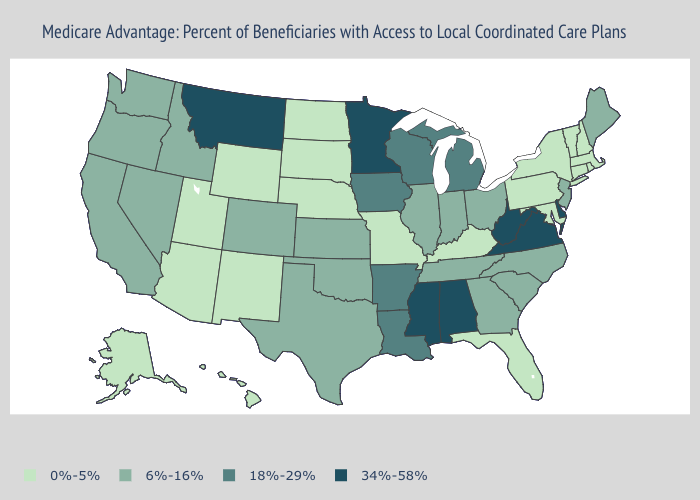What is the value of Illinois?
Short answer required. 6%-16%. Does Minnesota have a lower value than Utah?
Quick response, please. No. What is the highest value in the USA?
Short answer required. 34%-58%. Name the states that have a value in the range 6%-16%?
Be succinct. California, Colorado, Georgia, Idaho, Illinois, Indiana, Kansas, Maine, North Carolina, New Jersey, Nevada, Ohio, Oklahoma, Oregon, South Carolina, Tennessee, Texas, Washington. Is the legend a continuous bar?
Keep it brief. No. Does Iowa have the same value as New York?
Concise answer only. No. Which states have the lowest value in the MidWest?
Concise answer only. Missouri, North Dakota, Nebraska, South Dakota. What is the value of Hawaii?
Write a very short answer. 0%-5%. What is the lowest value in the USA?
Quick response, please. 0%-5%. What is the value of New Mexico?
Answer briefly. 0%-5%. What is the lowest value in states that border North Carolina?
Answer briefly. 6%-16%. Name the states that have a value in the range 0%-5%?
Give a very brief answer. Alaska, Arizona, Connecticut, Florida, Hawaii, Kentucky, Massachusetts, Maryland, Missouri, North Dakota, Nebraska, New Hampshire, New Mexico, New York, Pennsylvania, Rhode Island, South Dakota, Utah, Vermont, Wyoming. Name the states that have a value in the range 6%-16%?
Give a very brief answer. California, Colorado, Georgia, Idaho, Illinois, Indiana, Kansas, Maine, North Carolina, New Jersey, Nevada, Ohio, Oklahoma, Oregon, South Carolina, Tennessee, Texas, Washington. What is the highest value in the Northeast ?
Keep it brief. 6%-16%. Does the first symbol in the legend represent the smallest category?
Quick response, please. Yes. 